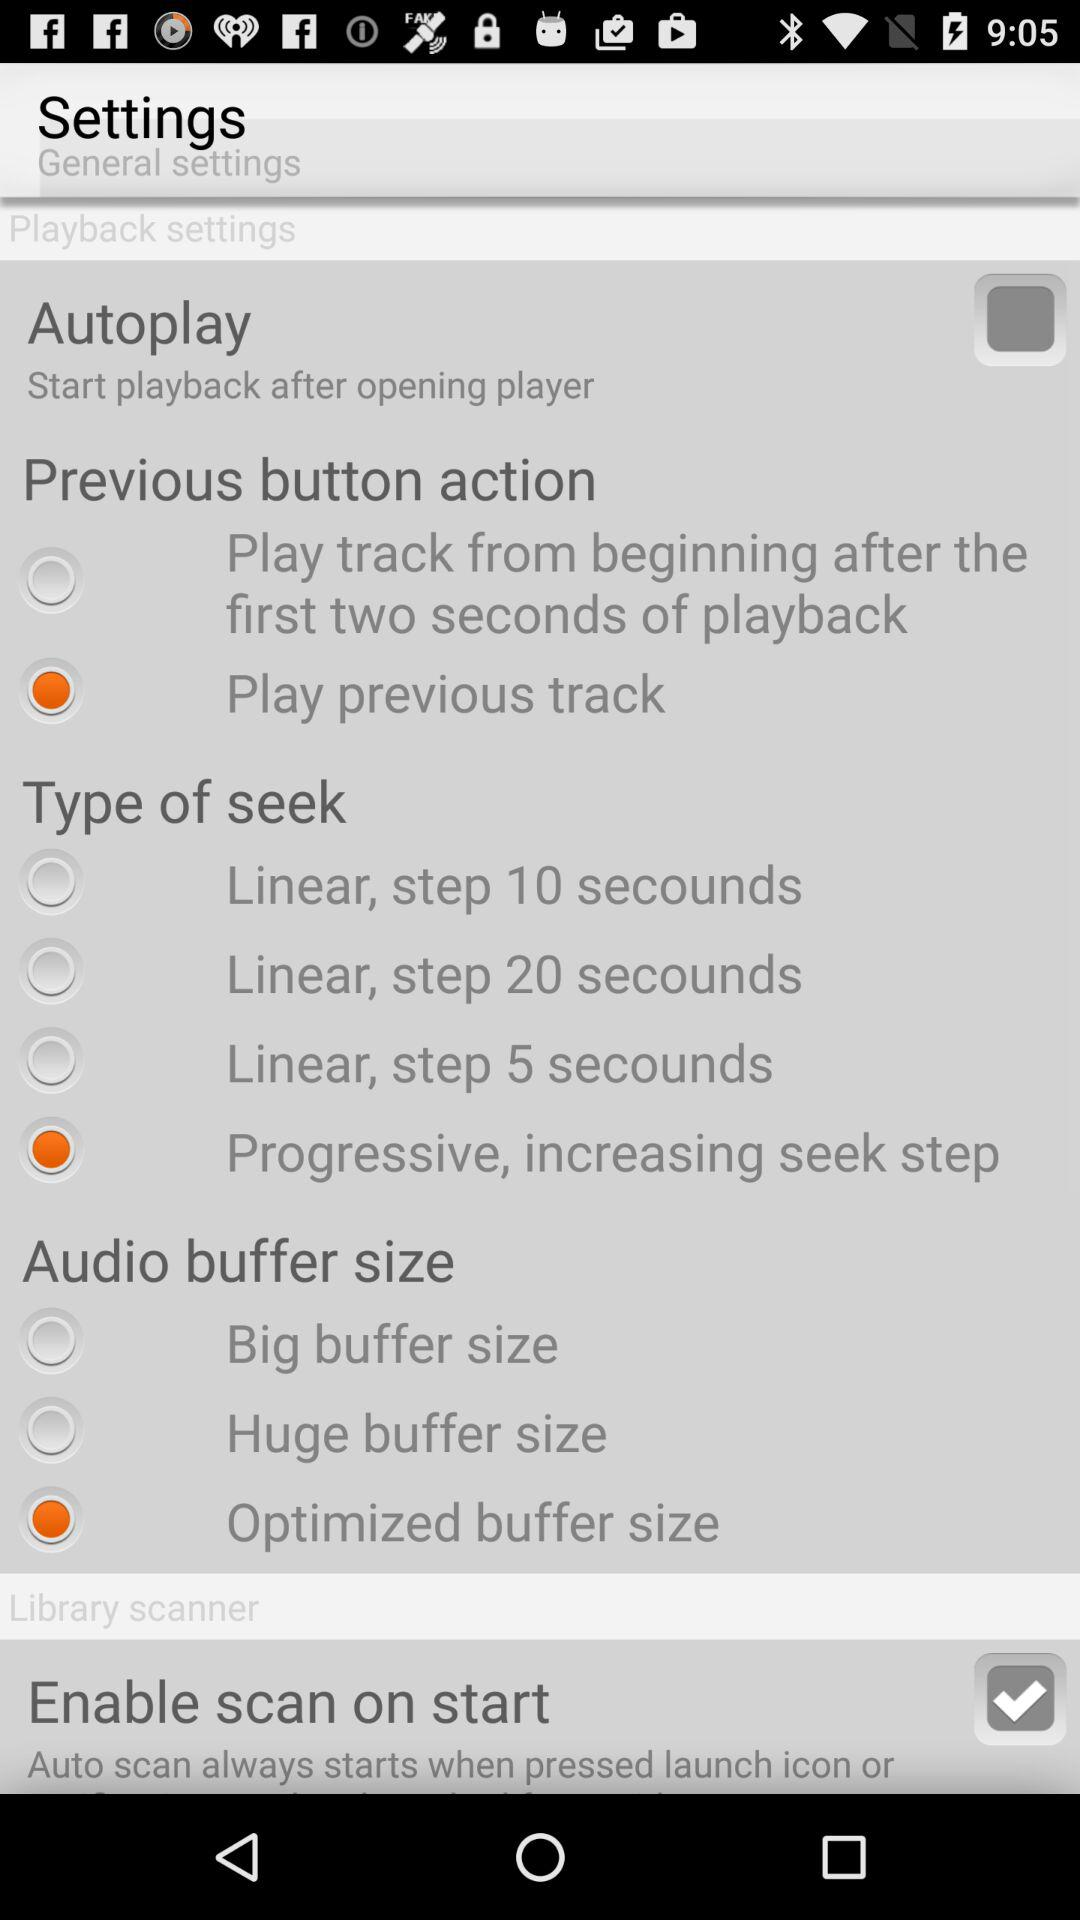How many checkbox options are there in the 'Library scanner' section?
Answer the question using a single word or phrase. 1 